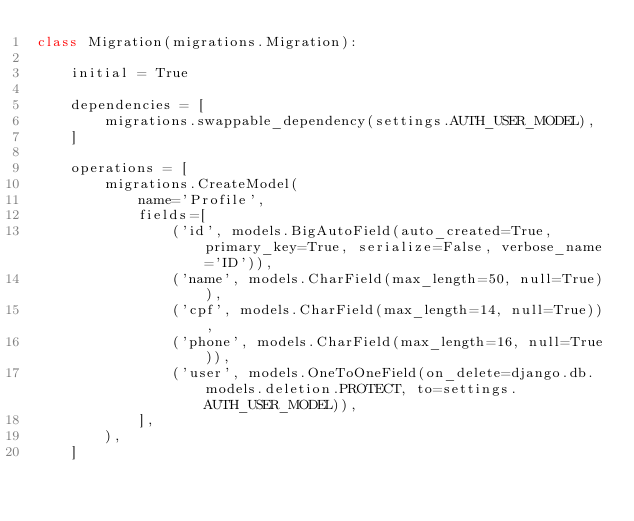Convert code to text. <code><loc_0><loc_0><loc_500><loc_500><_Python_>class Migration(migrations.Migration):

    initial = True

    dependencies = [
        migrations.swappable_dependency(settings.AUTH_USER_MODEL),
    ]

    operations = [
        migrations.CreateModel(
            name='Profile',
            fields=[
                ('id', models.BigAutoField(auto_created=True, primary_key=True, serialize=False, verbose_name='ID')),
                ('name', models.CharField(max_length=50, null=True)),
                ('cpf', models.CharField(max_length=14, null=True)),
                ('phone', models.CharField(max_length=16, null=True)),
                ('user', models.OneToOneField(on_delete=django.db.models.deletion.PROTECT, to=settings.AUTH_USER_MODEL)),
            ],
        ),
    ]
</code> 